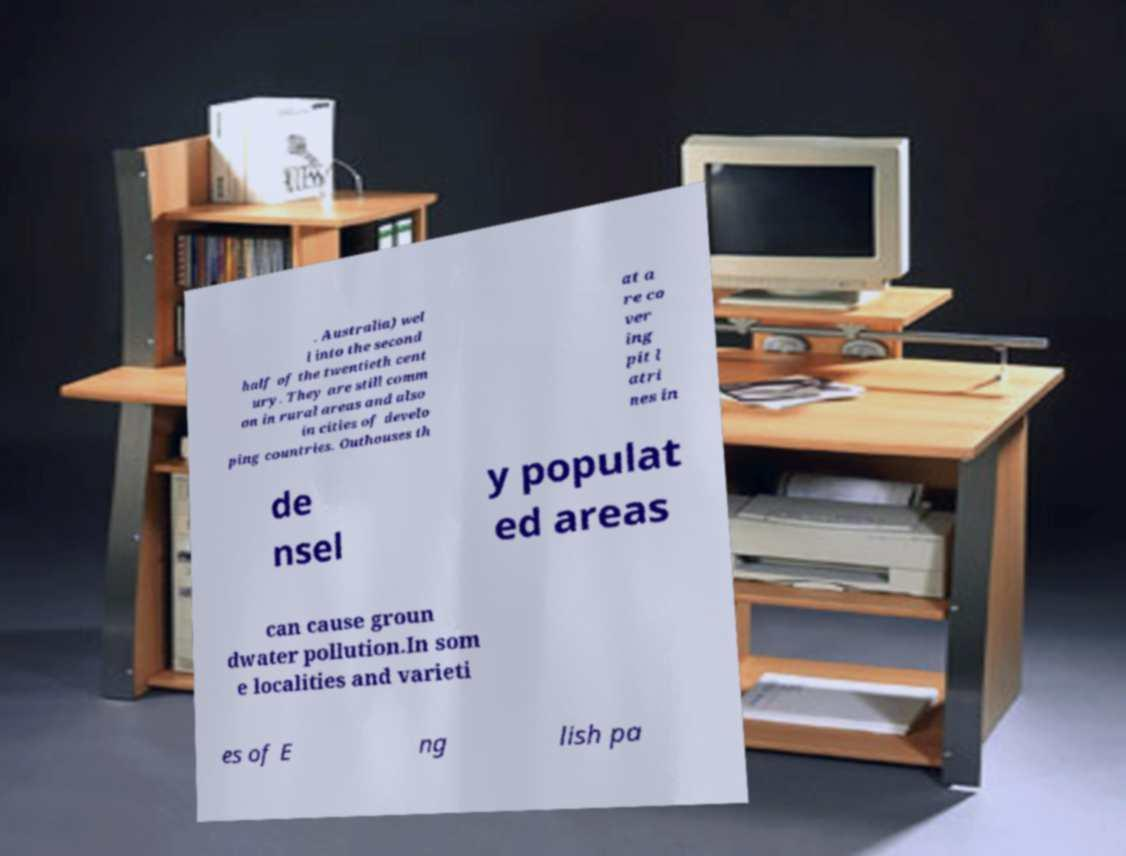There's text embedded in this image that I need extracted. Can you transcribe it verbatim? . Australia) wel l into the second half of the twentieth cent ury. They are still comm on in rural areas and also in cities of develo ping countries. Outhouses th at a re co ver ing pit l atri nes in de nsel y populat ed areas can cause groun dwater pollution.In som e localities and varieti es of E ng lish pa 